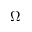Convert formula to latex. <formula><loc_0><loc_0><loc_500><loc_500>{ \Omega }</formula> 